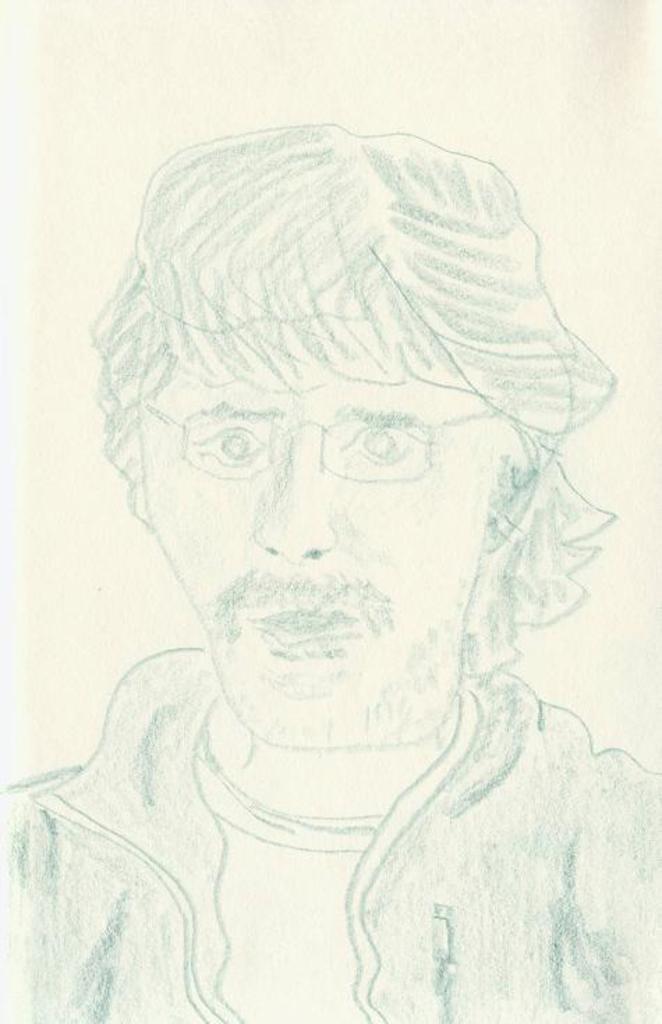In one or two sentences, can you explain what this image depicts? Here we can see a drawing of a person. 